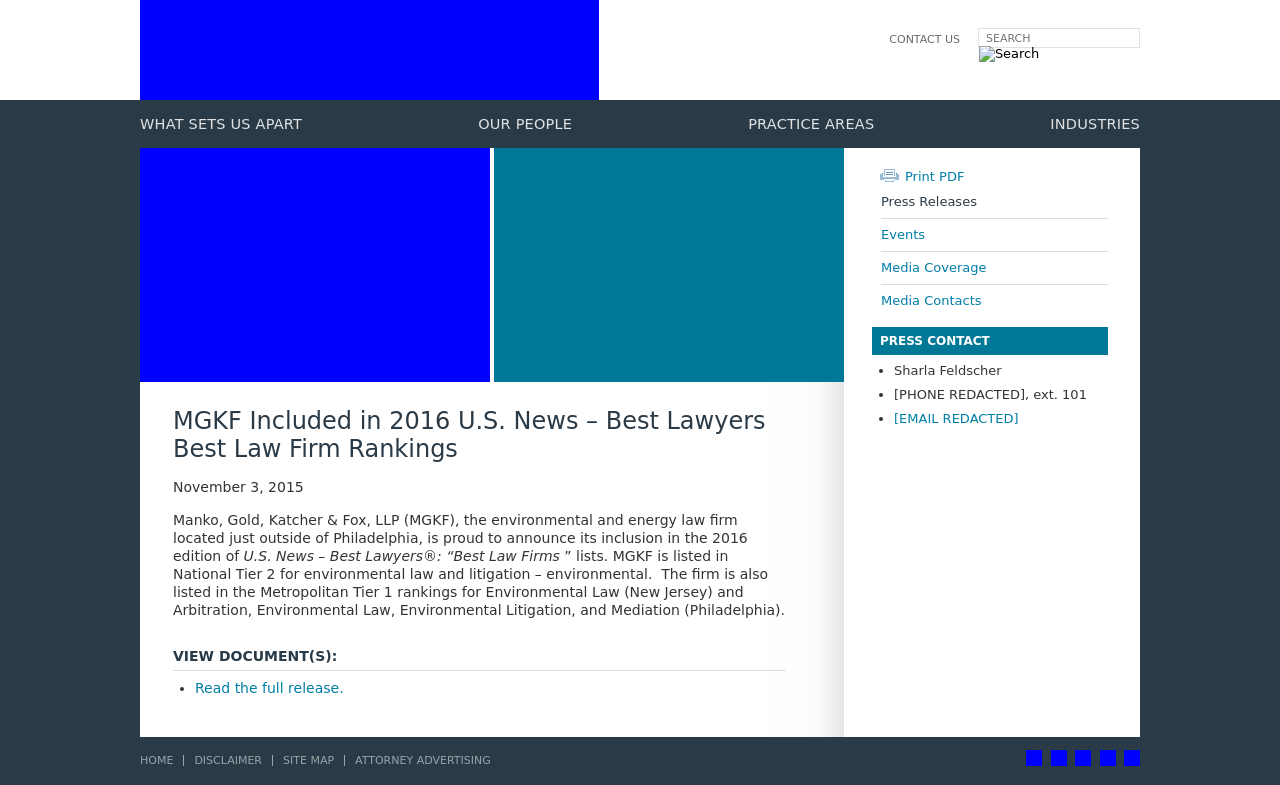How would the information on the website be useful for potential clients or associates? Information like this showcases the firm's expertise and high standing in the legal community, which can be critical for attracting potential clients seeking proficient legal services, especially in environmental law. For prospective associates or employees, such rankings demonstrate the firm’s reputation and suggest it as a prestigious place to develop a career in law.  Is there any significance to the available links to social media on the footer of the website? Yes, these links are crucial for modern business practices. They offer ways to connect with the firm on professional and social levels, allowing for engagement through platforms like LinkedIn, Facebook, and Twitter. This connectivity is essential for maintaining relationships with clients, engaging with the community, and improving the firm’s visibility online. 